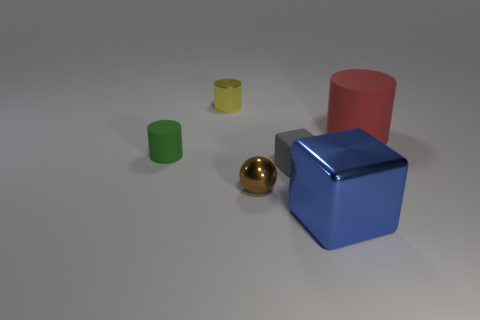Are there any other things that are the same shape as the small brown metal thing?
Provide a short and direct response. No. Is the number of yellow cylinders on the right side of the small yellow cylinder the same as the number of big things?
Your response must be concise. No. How many things are behind the red matte thing and in front of the brown object?
Make the answer very short. 0. What is the size of the other yellow thing that is the same shape as the big rubber thing?
Keep it short and to the point. Small. What number of other things have the same material as the tiny brown thing?
Make the answer very short. 2. Is the number of small matte blocks in front of the tiny gray thing less than the number of green matte blocks?
Your answer should be very brief. No. What number of small metallic things are there?
Ensure brevity in your answer.  2. How many shiny objects have the same color as the shiny block?
Your response must be concise. 0. Do the green object and the big rubber object have the same shape?
Offer a terse response. Yes. There is a cylinder that is behind the matte cylinder that is to the right of the small green matte cylinder; how big is it?
Provide a succinct answer. Small. 